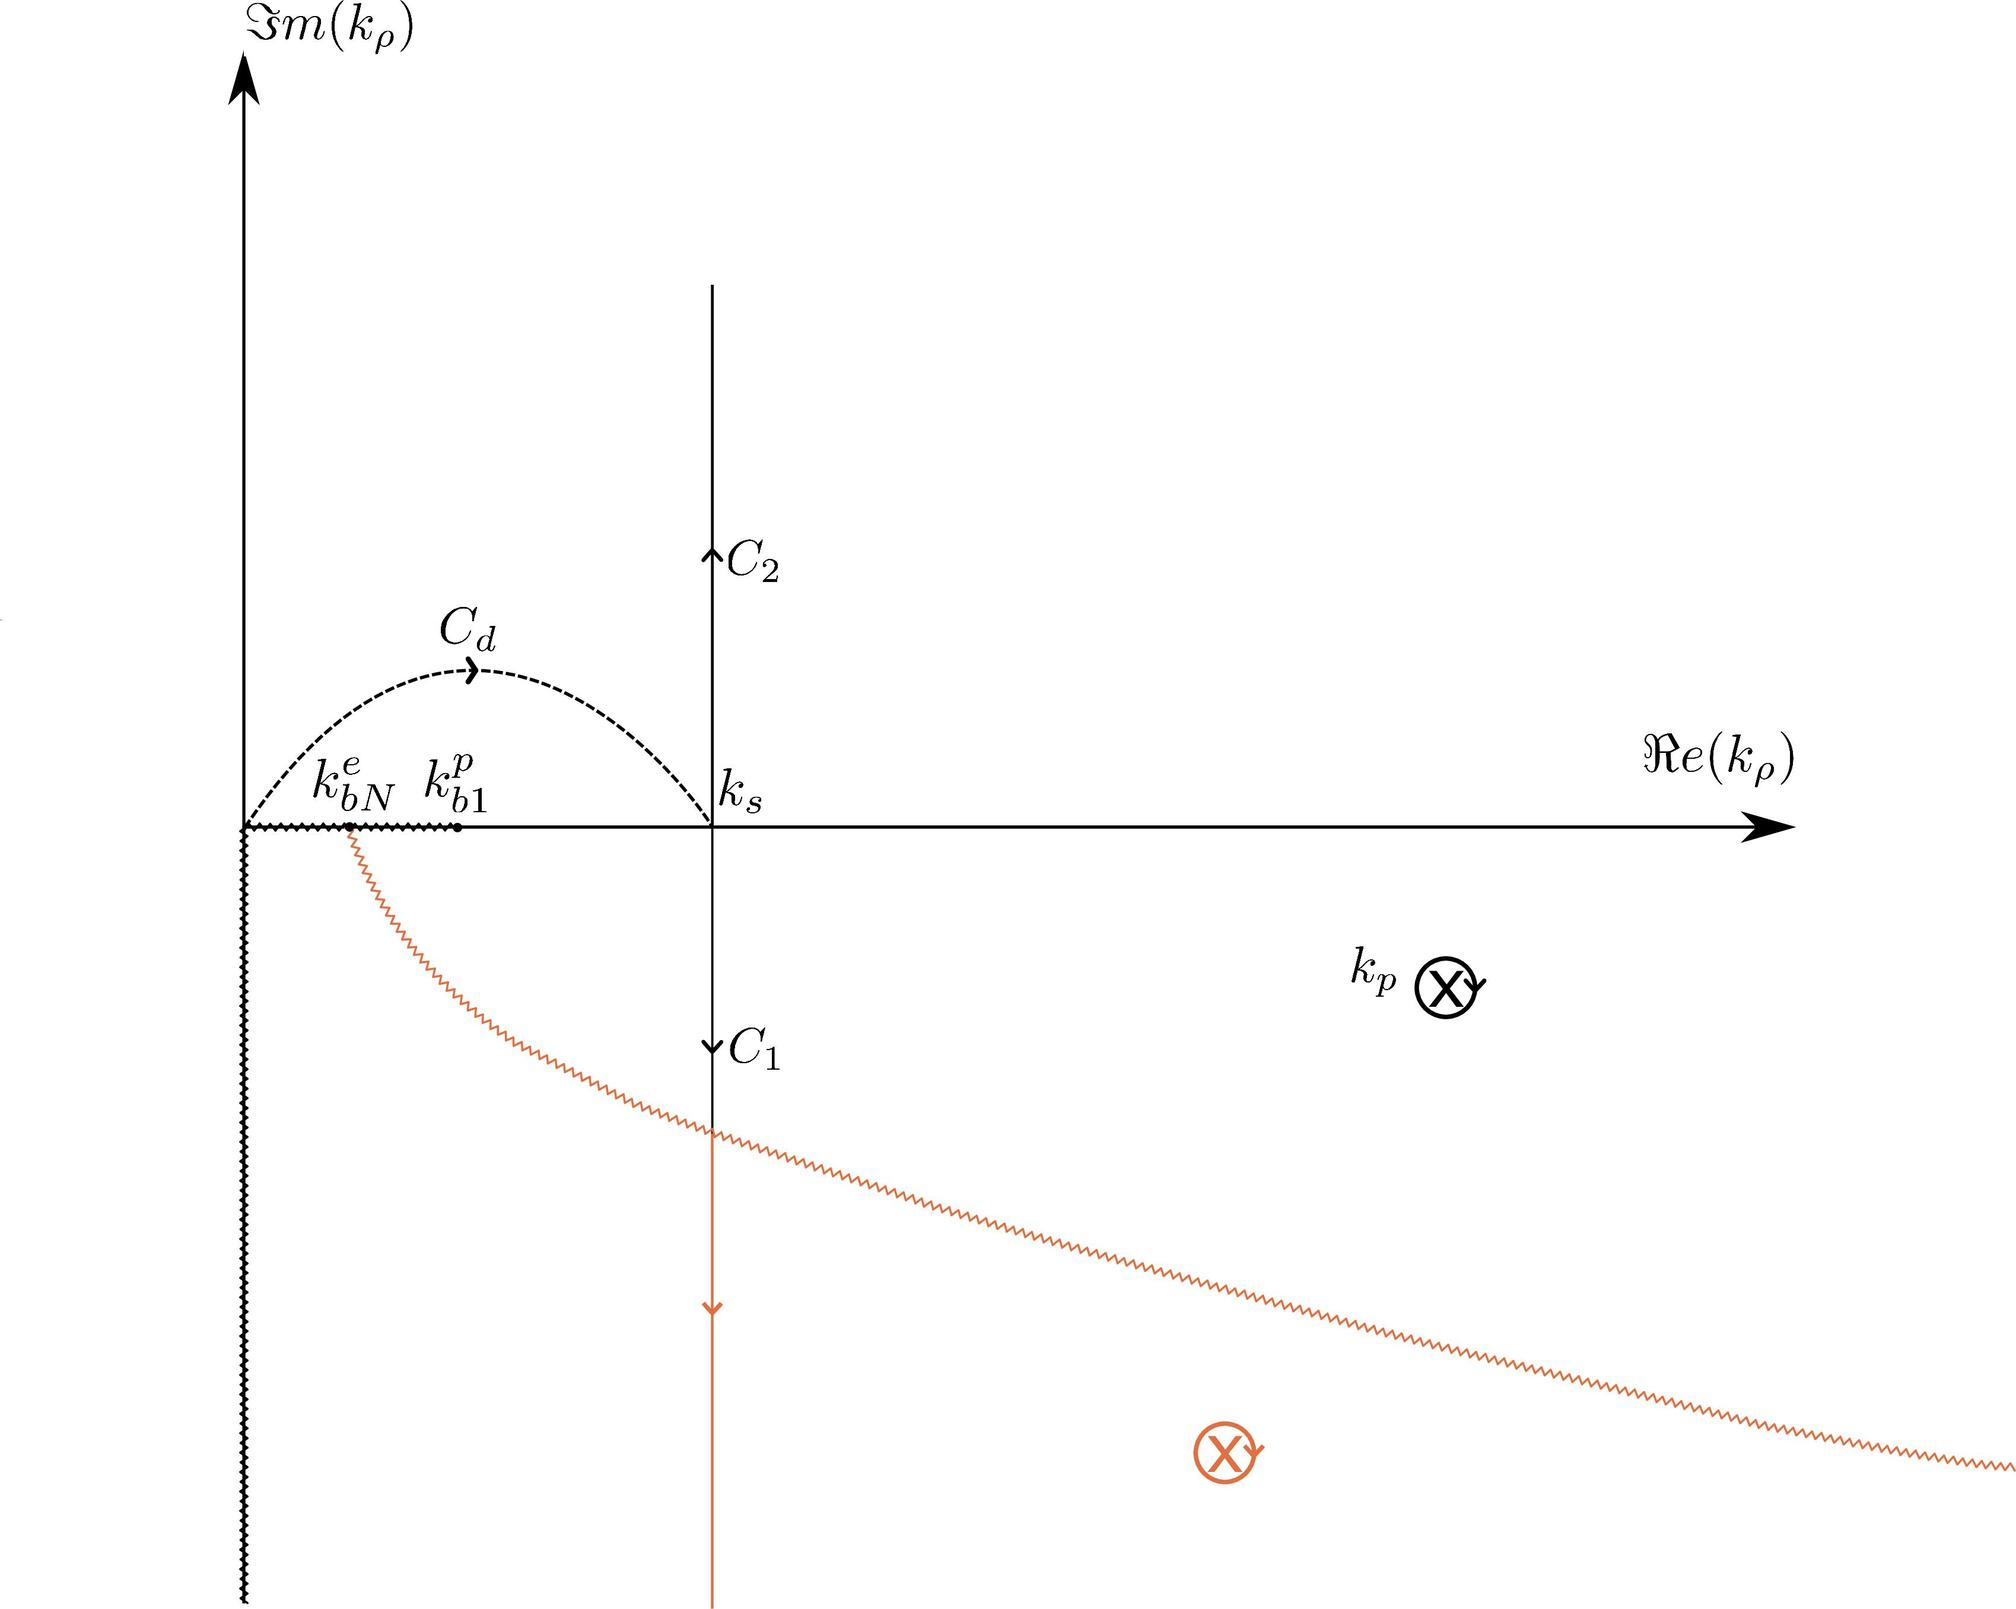Can you explain the significance of the two crosses on the figure, particularly the one on the real axis? In the complex plane shown in the image, crosses typically represent singular points or branch points of a function. The cross on the real axis at the position labeled \( k_p \) likely indicates a singularity or a critical point for the function being studied. At such points, the function's behavior changes abruptly, which often entails mathematical implications like the requirement for a branch cut or special integral considerations.  Why does the path labeled \( C_1 \) appear as a dotted line? In complex analysis diagrams, a dotted line like that of \( C_1 \) often signifies a path taken within the context of an analytic continuation, a method used to extend the domain of a complex function. This suggest that the path may not be 'real' or primary in the context of the integral but is crucial for understanding or defining the function's behavior in adjacent areas of the complex plane. 